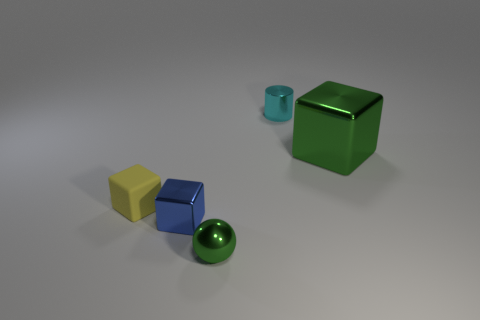What might be the relative sizes of these objects? The objects in the image seem to represent a mix of sizes. The green cube is the largest, followed by the blue block. The yellow block is smaller than the two, and the green sphere and the blue cylinder are the smallest. The relative sizes suggest that if the green cube is a standard six-sided die, the other objects would be proportionally small, comparable to tabletop gaming pieces or trinkets.  Could you guess the purpose of this arrangement? This arrangement may serve several purposes. It could be a simple artistic composition playing with colors, shapes, and reflections. Alternatively, it can be an educational setup demonstrating size comparison, the geometry of different shapes, or an illustrative scene for a photographer practicing still life photography. 